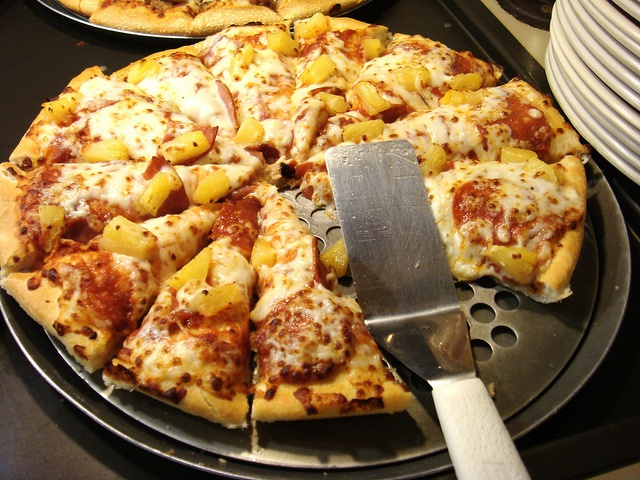Describe the objects in this image and their specific colors. I can see pizza in black, khaki, tan, red, and orange tones, spoon in black, gray, darkgray, and beige tones, pizza in black, brown, tan, maroon, and khaki tones, pizza in black, brown, orange, tan, and maroon tones, and pizza in black, gold, orange, and khaki tones in this image. 